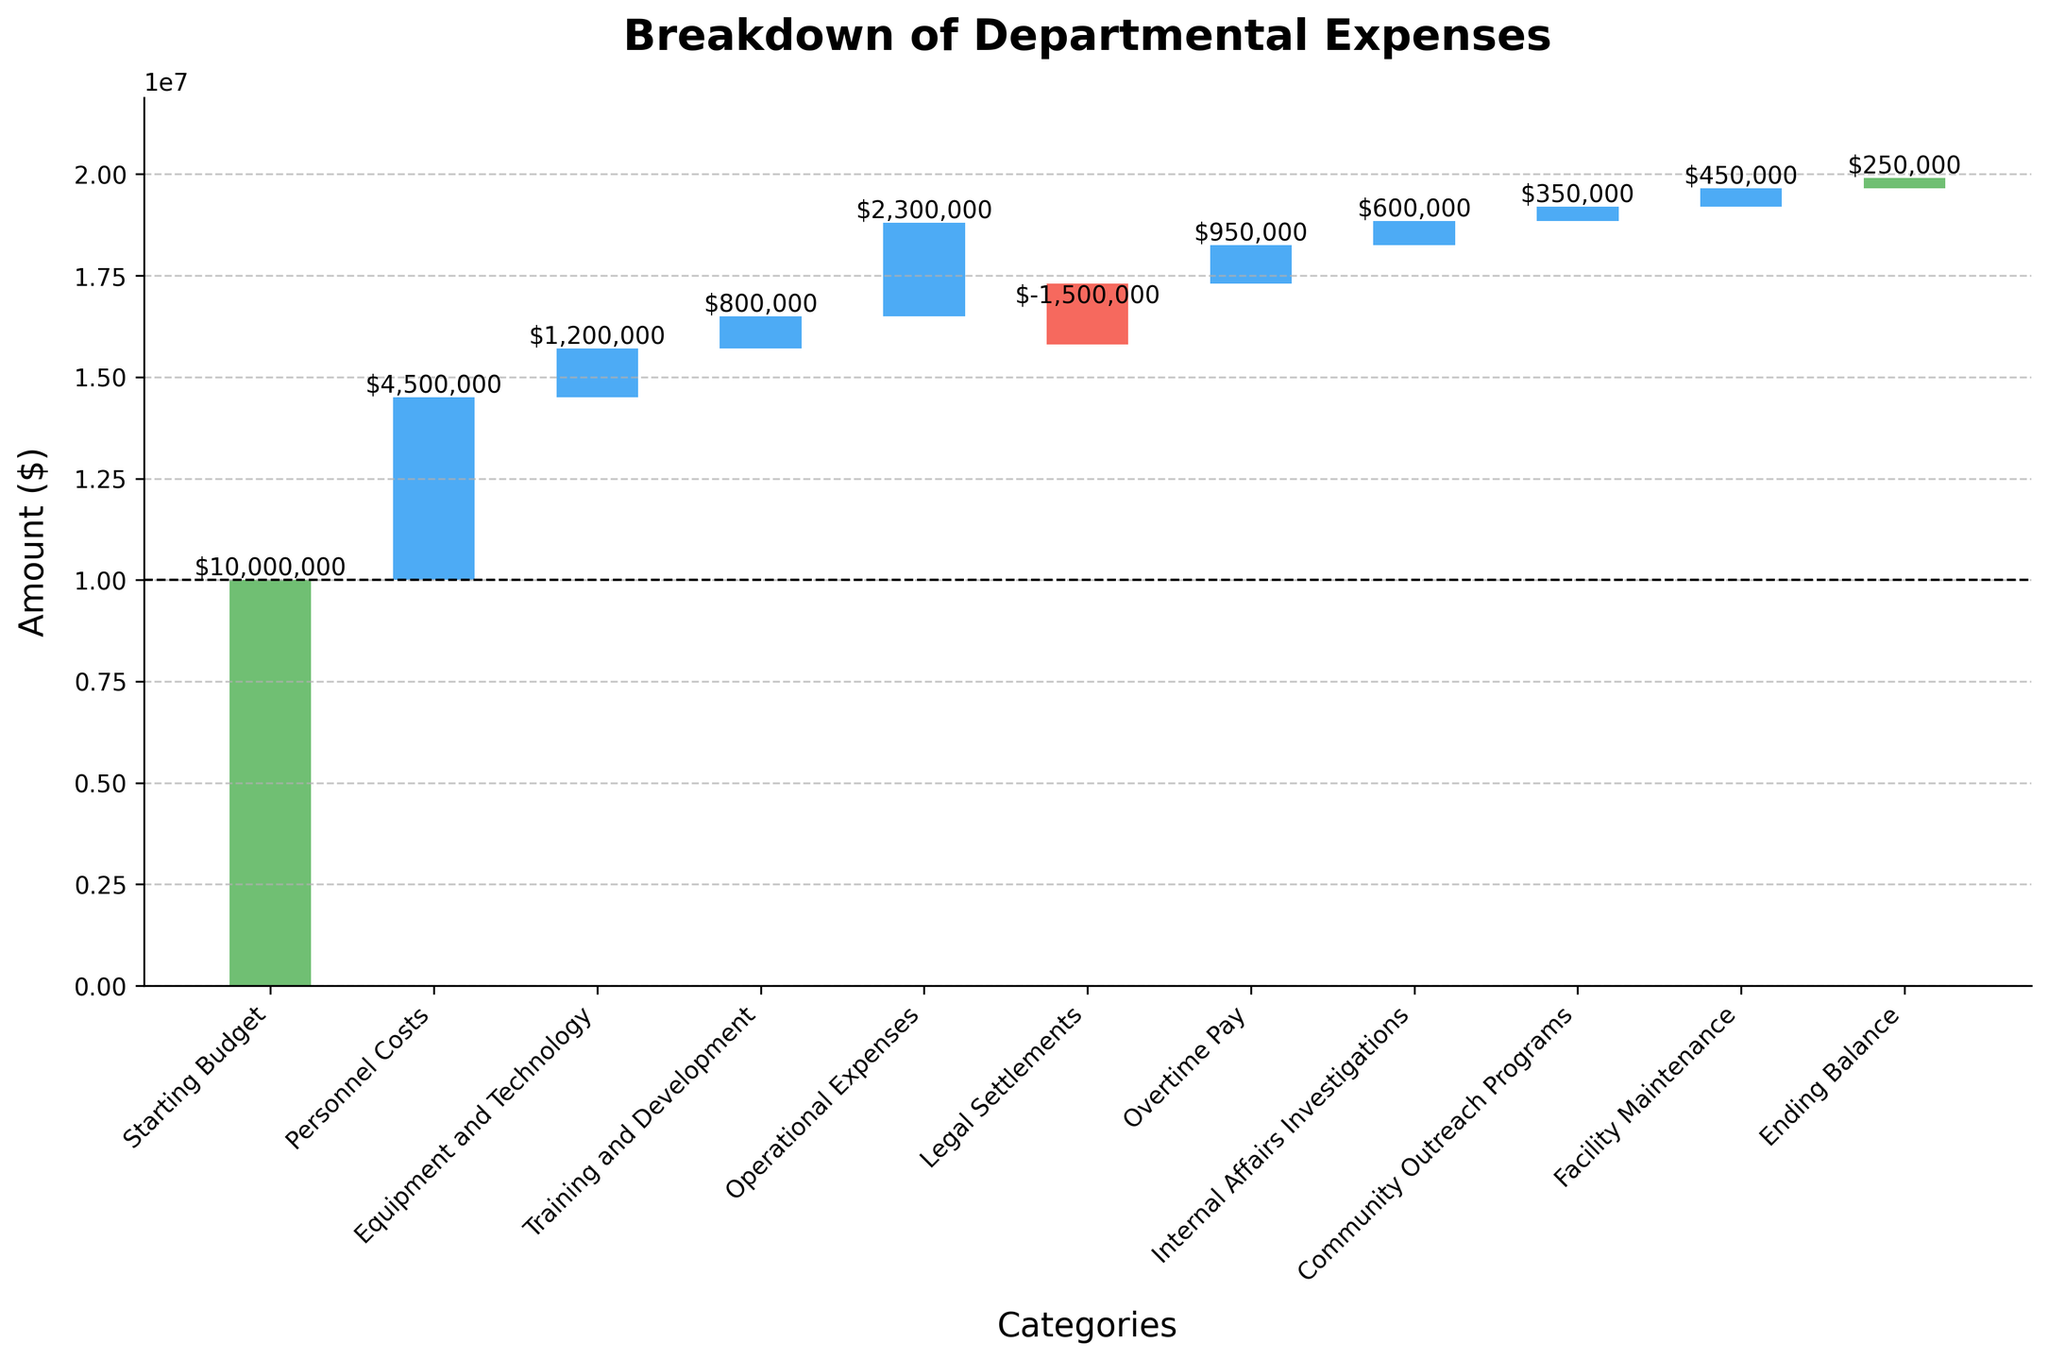what is the starting budget? The first category in the figure is "Starting Budget," which is visually represented at the initial offset on the y-axis. By reading the label next to this initial bar, we find the amount of the starting budget to be $10,000,000.
Answer: $10,000,000 What is the ending balance? The last category in the figure is labeled "Ending Balance." From the visual representation, we can easily read the amount next to this final bar, which is $250,000.
Answer: $250,000 How much was spent on personnel costs? Personnel costs are represented as the second bar in the waterfall chart titled "Personnel Costs." The value next to this bar is $4,500,000.
Answer: $4,500,000 Which category had the largest expense? By visually comparing the lengths of all the positive bars, we see that the "Personnel Costs" bar is the longest, indicating it has the largest expense.
Answer: Personnel Costs Which category resulted in a reduction of expenses? The categories resulting in a reduction of expenses are visually indicated by the red bars in the waterfall chart. The only red bar, indicating a negative value, corresponds to "Legal Settlements."
Answer: Legal Settlements What is the total expenditure on equipment and technology, training and development, and operational expenses combined? Add the amounts for "Equipment and Technology" ($1,200,000), "Training and Development" ($800,000), and "Operational Expenses" ($2,300,000). The total is $1,200,000 + $800,000 + $2,300,000 = $4,300,000.
Answer: $4,300,000 Which category followed by the starting budget had the smallest positive expense? After the starting budget, the category "Community Outreach Programs" has the smallest positive expense, which is $350,000.
Answer: Community Outreach Programs Is the spending on overtime pay greater than on community outreach programs? Compare the lengths of the bars labeled "Overtime Pay" and "Community Outreach Programs." The "Overtime Pay" bar is taller. The amount for Overtime Pay is $950,000, and for Community Outreach Programs it is $350,000.
Answer: Yes How much do internal affairs investigations and facility maintenance add up to? Add the amounts for "Internal Affairs Investigations" ($600,000) and "Facility Maintenance" ($450,000). The total is $600,000 + $450,000 = $1,050,000.
Answer: $1,050,000 What is the effect of legal settlements on the overall budget? The "Legal Settlements" category is represented by a red bar, indicating a negative impact on the budget. The value next to this bar is -$1,500,000, which subtracts from the overall budget.
Answer: -$1,500,000 